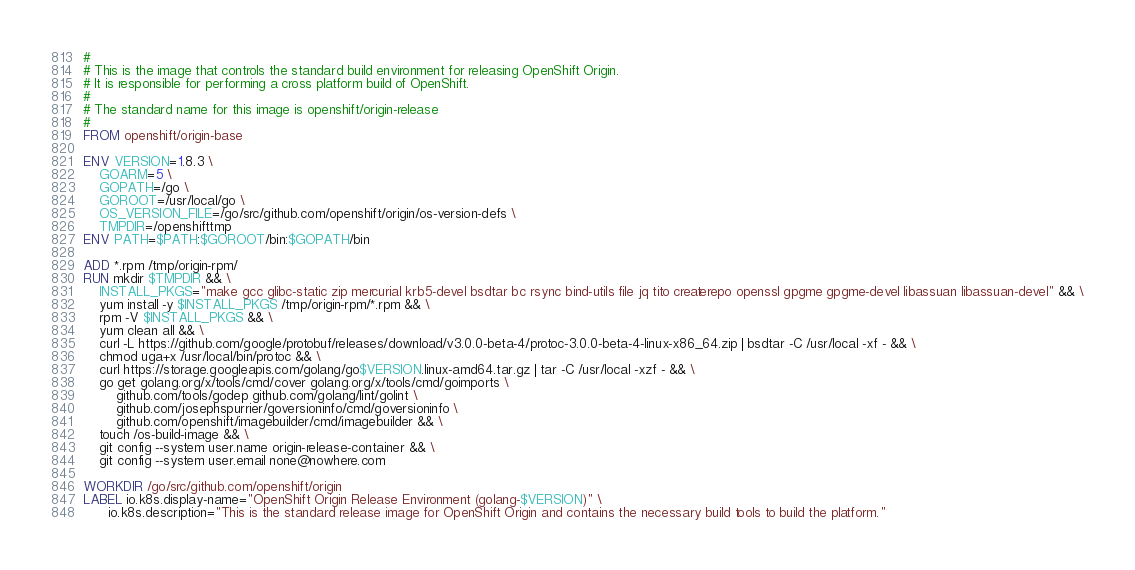<code> <loc_0><loc_0><loc_500><loc_500><_Dockerfile_>#
# This is the image that controls the standard build environment for releasing OpenShift Origin.
# It is responsible for performing a cross platform build of OpenShift.
#
# The standard name for this image is openshift/origin-release
#
FROM openshift/origin-base

ENV VERSION=1.8.3 \
    GOARM=5 \
    GOPATH=/go \
    GOROOT=/usr/local/go \
    OS_VERSION_FILE=/go/src/github.com/openshift/origin/os-version-defs \
    TMPDIR=/openshifttmp
ENV PATH=$PATH:$GOROOT/bin:$GOPATH/bin

ADD *.rpm /tmp/origin-rpm/
RUN mkdir $TMPDIR && \
    INSTALL_PKGS="make gcc glibc-static zip mercurial krb5-devel bsdtar bc rsync bind-utils file jq tito createrepo openssl gpgme gpgme-devel libassuan libassuan-devel" && \
    yum install -y $INSTALL_PKGS /tmp/origin-rpm/*.rpm && \
    rpm -V $INSTALL_PKGS && \
    yum clean all && \
    curl -L https://github.com/google/protobuf/releases/download/v3.0.0-beta-4/protoc-3.0.0-beta-4-linux-x86_64.zip | bsdtar -C /usr/local -xf - && \
    chmod uga+x /usr/local/bin/protoc && \
    curl https://storage.googleapis.com/golang/go$VERSION.linux-amd64.tar.gz | tar -C /usr/local -xzf - && \
    go get golang.org/x/tools/cmd/cover golang.org/x/tools/cmd/goimports \
        github.com/tools/godep github.com/golang/lint/golint \
        github.com/josephspurrier/goversioninfo/cmd/goversioninfo \
        github.com/openshift/imagebuilder/cmd/imagebuilder && \
    touch /os-build-image && \
    git config --system user.name origin-release-container && \
    git config --system user.email none@nowhere.com

WORKDIR /go/src/github.com/openshift/origin
LABEL io.k8s.display-name="OpenShift Origin Release Environment (golang-$VERSION)" \
      io.k8s.description="This is the standard release image for OpenShift Origin and contains the necessary build tools to build the platform."
</code> 